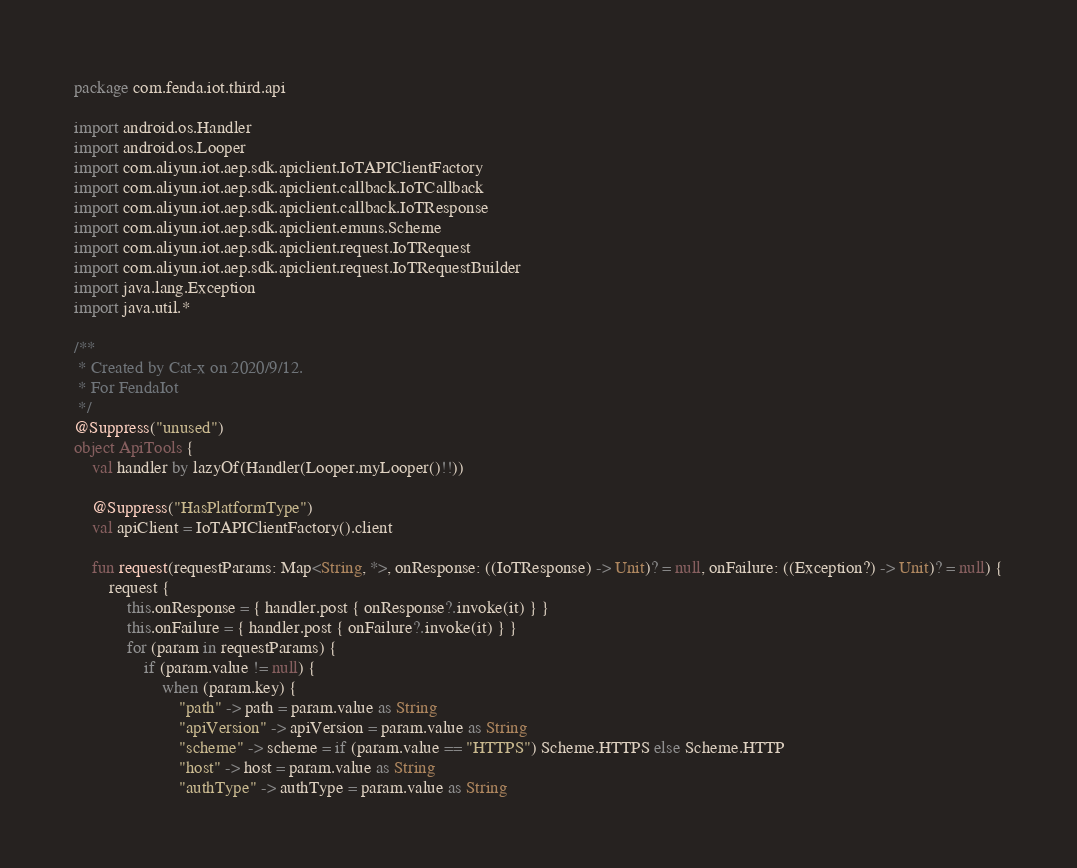<code> <loc_0><loc_0><loc_500><loc_500><_Kotlin_>package com.fenda.iot.third.api

import android.os.Handler
import android.os.Looper
import com.aliyun.iot.aep.sdk.apiclient.IoTAPIClientFactory
import com.aliyun.iot.aep.sdk.apiclient.callback.IoTCallback
import com.aliyun.iot.aep.sdk.apiclient.callback.IoTResponse
import com.aliyun.iot.aep.sdk.apiclient.emuns.Scheme
import com.aliyun.iot.aep.sdk.apiclient.request.IoTRequest
import com.aliyun.iot.aep.sdk.apiclient.request.IoTRequestBuilder
import java.lang.Exception
import java.util.*

/**
 * Created by Cat-x on 2020/9/12.
 * For FendaIot
 */
@Suppress("unused")
object ApiTools {
    val handler by lazyOf(Handler(Looper.myLooper()!!))

    @Suppress("HasPlatformType")
    val apiClient = IoTAPIClientFactory().client

    fun request(requestParams: Map<String, *>, onResponse: ((IoTResponse) -> Unit)? = null, onFailure: ((Exception?) -> Unit)? = null) {
        request {
            this.onResponse = { handler.post { onResponse?.invoke(it) } }
            this.onFailure = { handler.post { onFailure?.invoke(it) } }
            for (param in requestParams) {
                if (param.value != null) {
                    when (param.key) {
                        "path" -> path = param.value as String
                        "apiVersion" -> apiVersion = param.value as String
                        "scheme" -> scheme = if (param.value == "HTTPS") Scheme.HTTPS else Scheme.HTTP
                        "host" -> host = param.value as String
                        "authType" -> authType = param.value as String</code> 